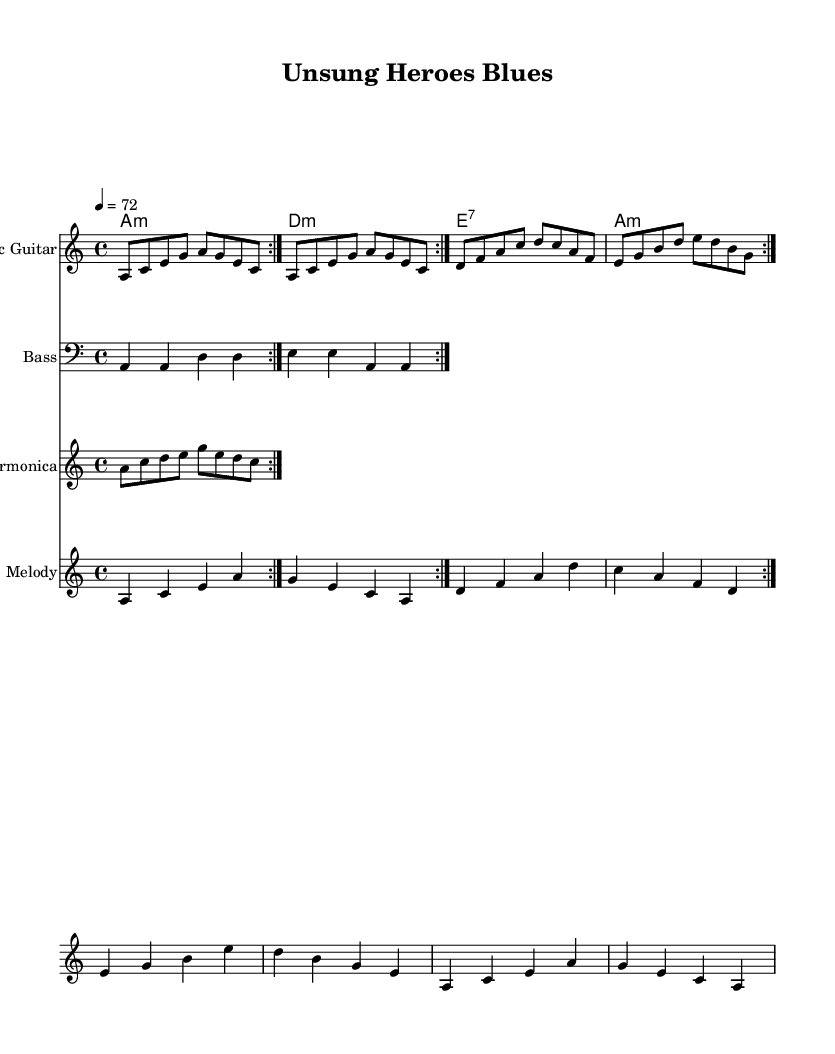What is the key signature of this music? The key signature is A minor, indicated at the beginning of the score, which shows no sharps or flats.
Answer: A minor What is the time signature of the piece? The time signature is 4/4, indicated at the start of the score, which means there are four beats per measure.
Answer: 4/4 What is the tempo marking in this music? The tempo is marked as 72 beats per minute, indicated in the tempo section of the score.
Answer: 72 Which instrument plays the melody? The melody line is written for the "Melody" staff, clearly labeled, indicating it is played by a specific instrument, likely a voice or another lead instrument.
Answer: Melody How many measures are repeated in the electric guitar part? The electric guitar part shows a repeat sign, and it directly states that the measures should be repeated twice.
Answer: Two What harmony is used in the last chord of the piece? The last chord in the harmony section is A minor, visible in the chord names written, indicating the end of the piece harmonically.
Answer: A minor What type of blues is represented in the music? The music is characterized as electric blues, depicted by the instruments used (electric guitar, bass, harmonica) and the general blues structure.
Answer: Electric blues 